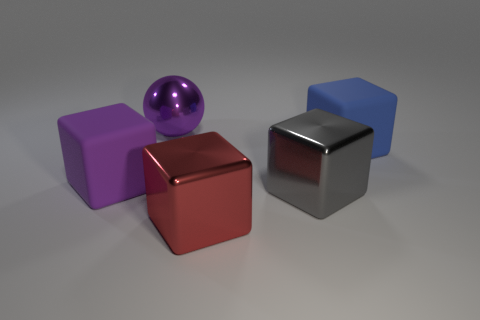Are there fewer things behind the large red metallic cube than big blue blocks that are left of the gray shiny thing?
Keep it short and to the point. No. How many other things are the same shape as the purple rubber thing?
Ensure brevity in your answer.  3. Is the number of purple objects that are in front of the large blue rubber object less than the number of metal balls?
Make the answer very short. No. There is a large purple thing left of the metal sphere; what is it made of?
Make the answer very short. Rubber. How many other objects are there of the same size as the red block?
Your answer should be very brief. 4. Are there fewer gray cubes than green matte blocks?
Offer a very short reply. No. The big blue matte object is what shape?
Your response must be concise. Cube. There is a big matte cube on the right side of the large shiny ball; is its color the same as the large ball?
Keep it short and to the point. No. What shape is the large shiny object that is behind the red object and on the left side of the gray metallic block?
Your answer should be compact. Sphere. There is a large cube right of the large gray object; what color is it?
Your answer should be very brief. Blue. 